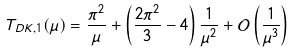<formula> <loc_0><loc_0><loc_500><loc_500>T _ { D K , 1 } ( \mu ) = \frac { \pi ^ { 2 } } { \mu } + \left ( \frac { 2 \pi ^ { 2 } } { 3 } - 4 \right ) \frac { 1 } { \mu ^ { 2 } } + \mathcal { O } \left ( \frac { 1 } { \mu ^ { 3 } } \right )</formula> 